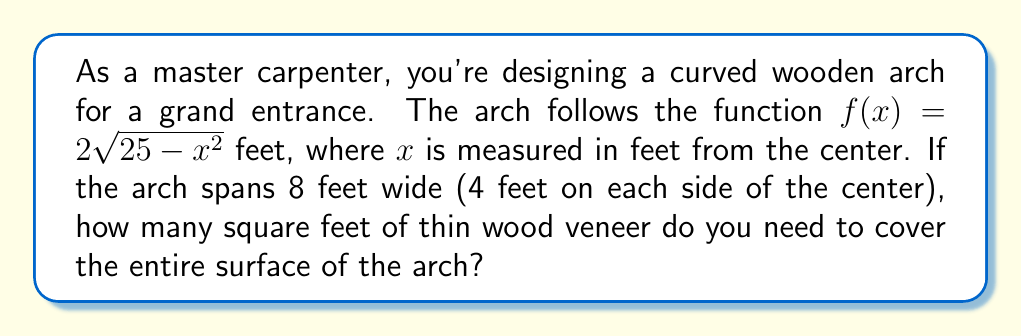Show me your answer to this math problem. To solve this problem, we need to use the arc length formula from integral calculus. Here's the step-by-step solution:

1) The arc length formula for a function $y = f(x)$ from $a$ to $b$ is:

   $$L = \int_a^b \sqrt{1 + \left(\frac{dy}{dx}\right)^2} dx$$

2) First, we need to find $\frac{dy}{dx}$. Given $f(x) = 2\sqrt{25-x^2}$, we can use the chain rule:

   $$\frac{dy}{dx} = 2 \cdot \frac{1}{2\sqrt{25-x^2}} \cdot (-2x) = -\frac{2x}{\sqrt{25-x^2}}$$

3) Now we can set up our integral:

   $$L = \int_{-4}^4 \sqrt{1 + \left(\frac{-2x}{\sqrt{25-x^2}}\right)^2} dx$$

4) Simplify inside the square root:

   $$L = \int_{-4}^4 \sqrt{1 + \frac{4x^2}{25-x^2}} dx$$

5) This can be further simplified to:

   $$L = \int_{-4}^4 \sqrt{\frac{25}{25-x^2}} dx$$

6) This integral is complex to solve analytically. We can use numerical integration methods or computer algebra systems to evaluate it. The result is approximately 10.47 feet.

7) Since we're covering a surface, we need to multiply this length by the width of the wood veneer. Assuming we're using a standard 4-foot wide veneer, the total area needed would be:

   $$\text{Area} = 10.47 \text{ feet} \times 4 \text{ feet} \approx 41.88 \text{ square feet}$$

8) Rounding up to account for waste and overlap, we need 42 square feet of wood veneer.
Answer: 42 square feet 